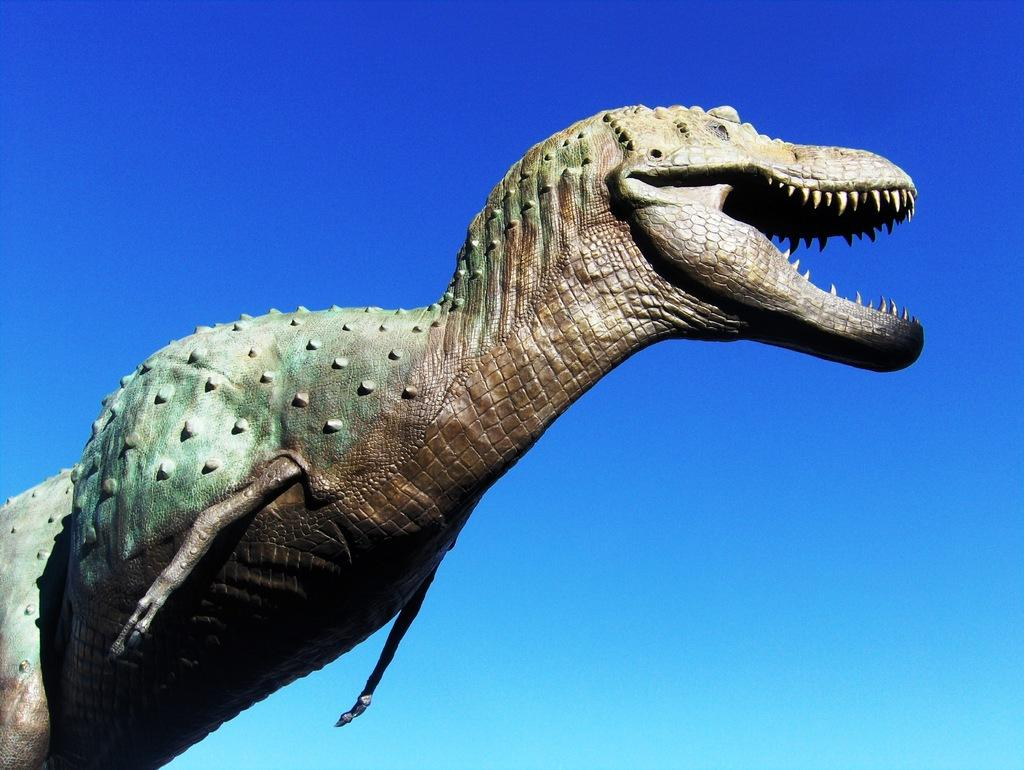What is the main subject in the center of the image? There is a statue of a dinosaur in the center of the image. What can be seen in the background of the image? There is sky visible in the background of the image. What type of tax is being discussed by the band in the image? There is no band present in the image, and therefore no discussion about taxes can be observed. 